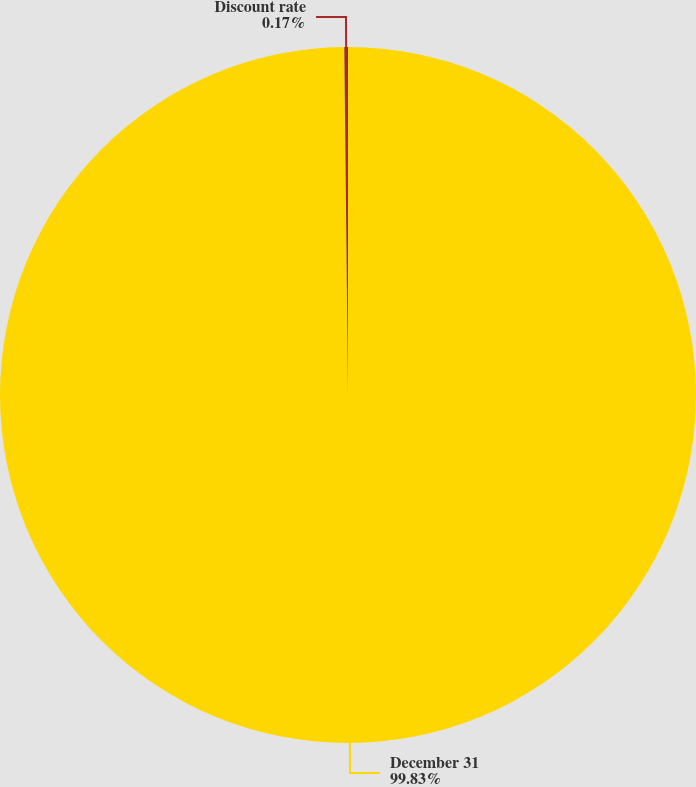Convert chart. <chart><loc_0><loc_0><loc_500><loc_500><pie_chart><fcel>December 31<fcel>Discount rate<nl><fcel>99.83%<fcel>0.17%<nl></chart> 